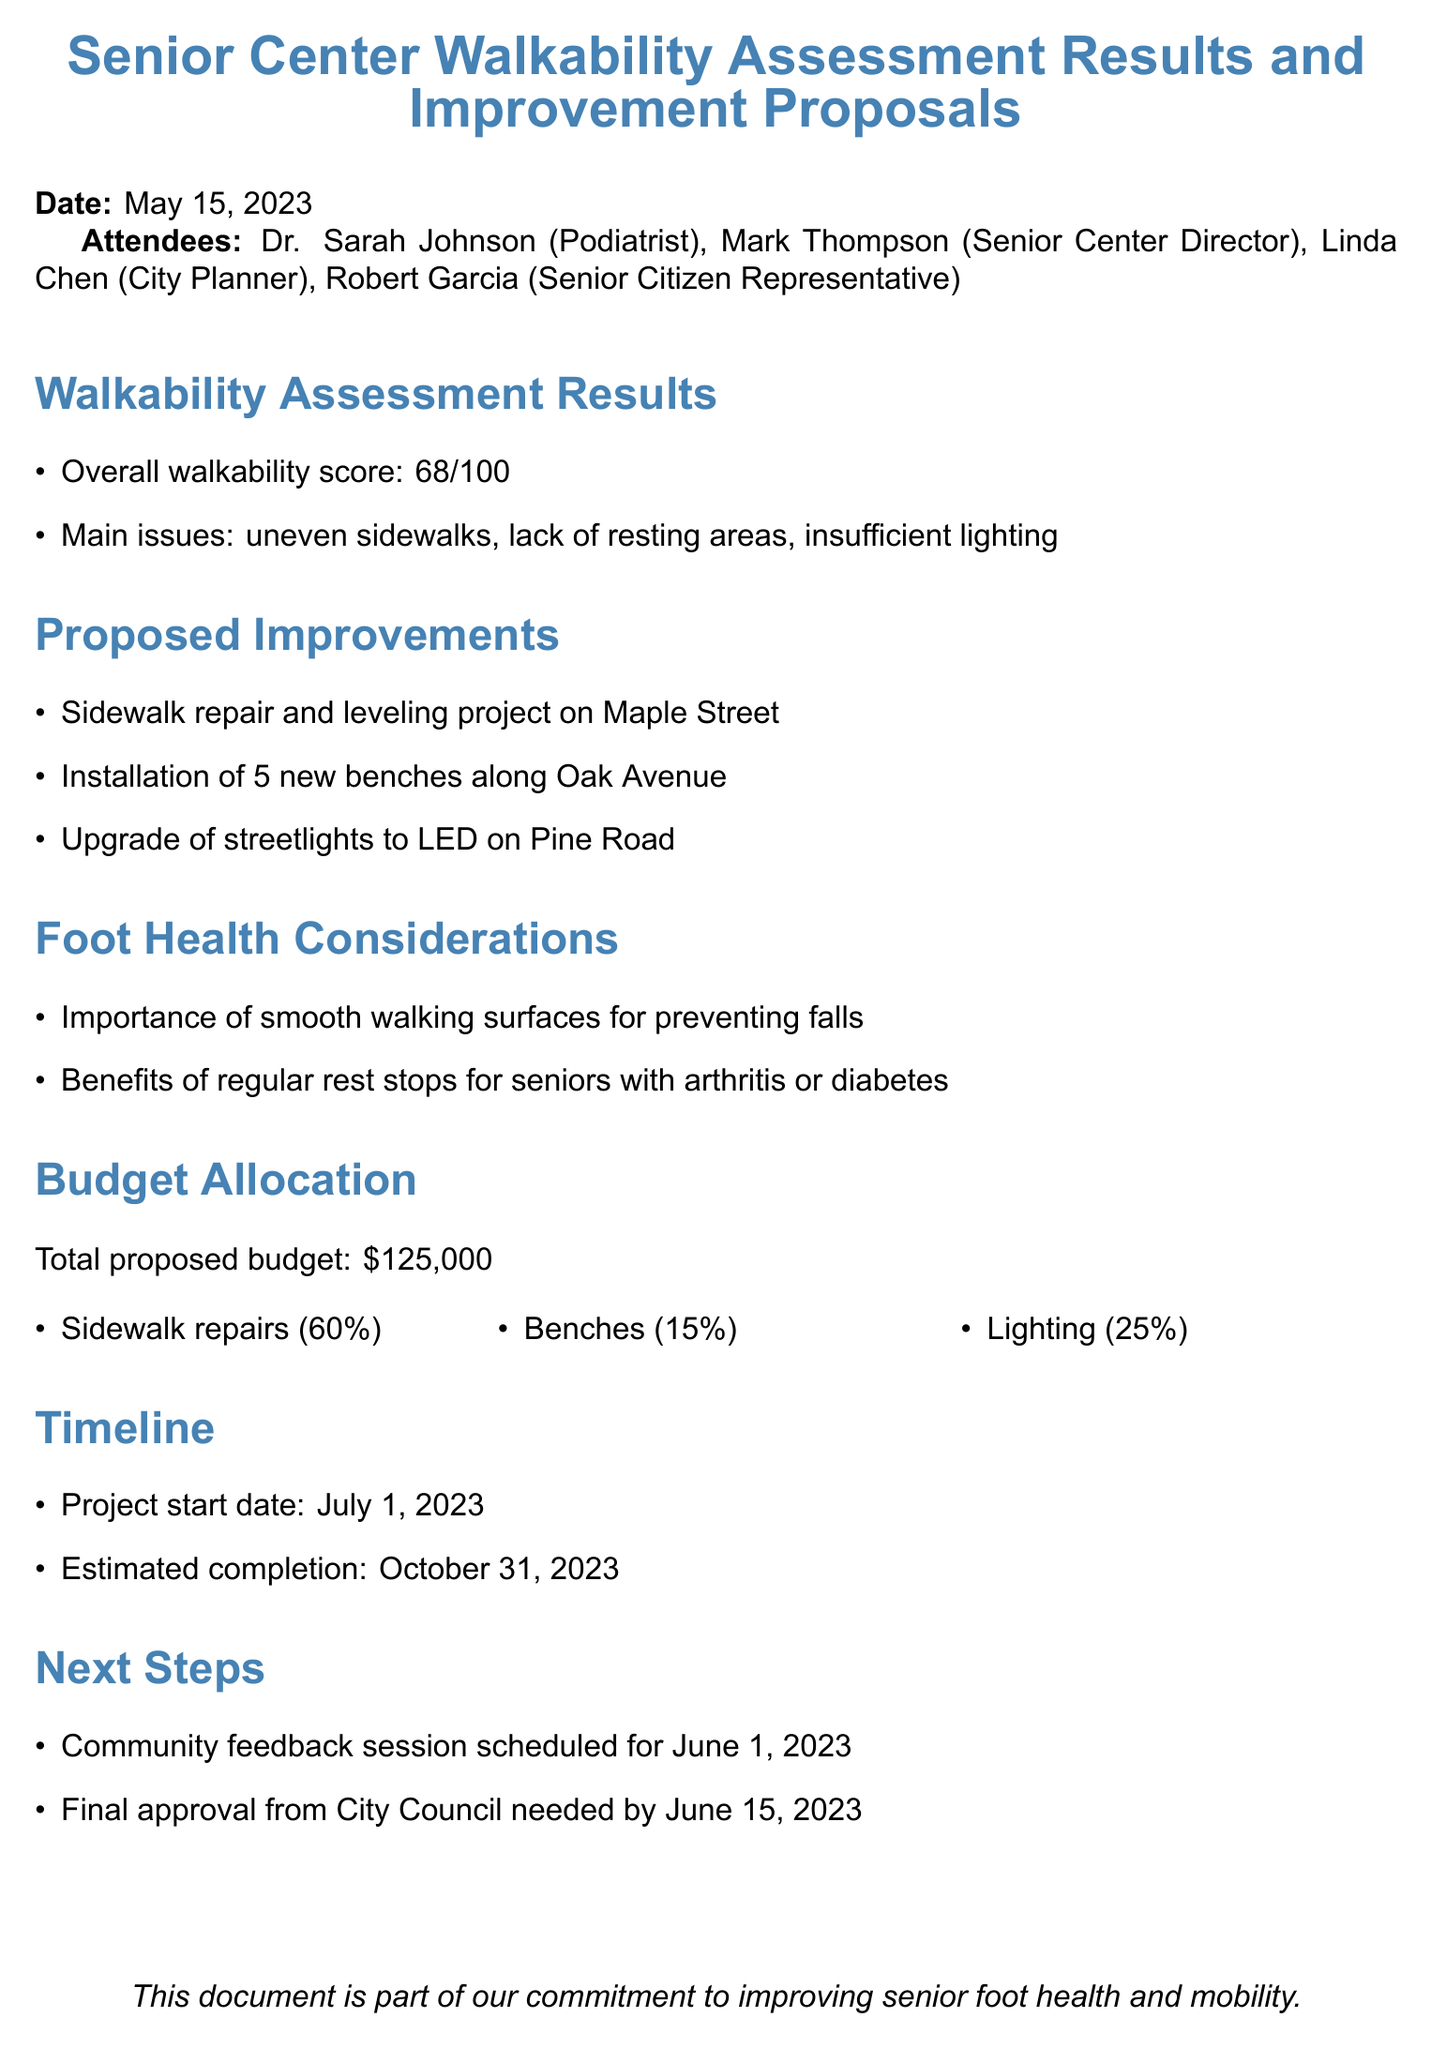What is the overall walkability score? The overall walkability score is listed in the assessment results section, which indicates a score of 68 out of 100.
Answer: 68/100 What are the main issues identified in the walkability assessment? The main issues are highlighted under the walkability assessment results, which mention uneven sidewalks, lack of resting areas, and insufficient lighting.
Answer: Uneven sidewalks, lack of resting areas, insufficient lighting How many new benches are proposed to be installed? The proposed improvements section details the installation of new benches, specifically mentioning 5 new benches along Oak Avenue.
Answer: 5 new benches What percentage of the budget is allocated to sidewalk repairs? The budget allocation section breaks down the total proposed budget and states that 60% of it will go to sidewalk repairs.
Answer: 60% When is the community feedback session scheduled? The next steps section specifies that a community feedback session is scheduled for June 1, 2023.
Answer: June 1, 2023 What is the estimated completion date for the project? The timeline section provides information about the estimated completion date for the project, which is October 31, 2023.
Answer: October 31, 2023 Why is smooth walking surface important? In the foot health considerations section, it is noted that smooth walking surfaces are important for preventing falls, which is particularly relevant for seniors.
Answer: Preventing falls What is the total proposed budget for the improvements? The budget allocation section clearly states the total proposed budget for the improvements, which is $125,000.
Answer: $125,000 Who is the senior citizen representative attending the meeting? The attendees section lists the individuals present at the meeting and identifies Robert Garcia as the senior citizen representative.
Answer: Robert Garcia 